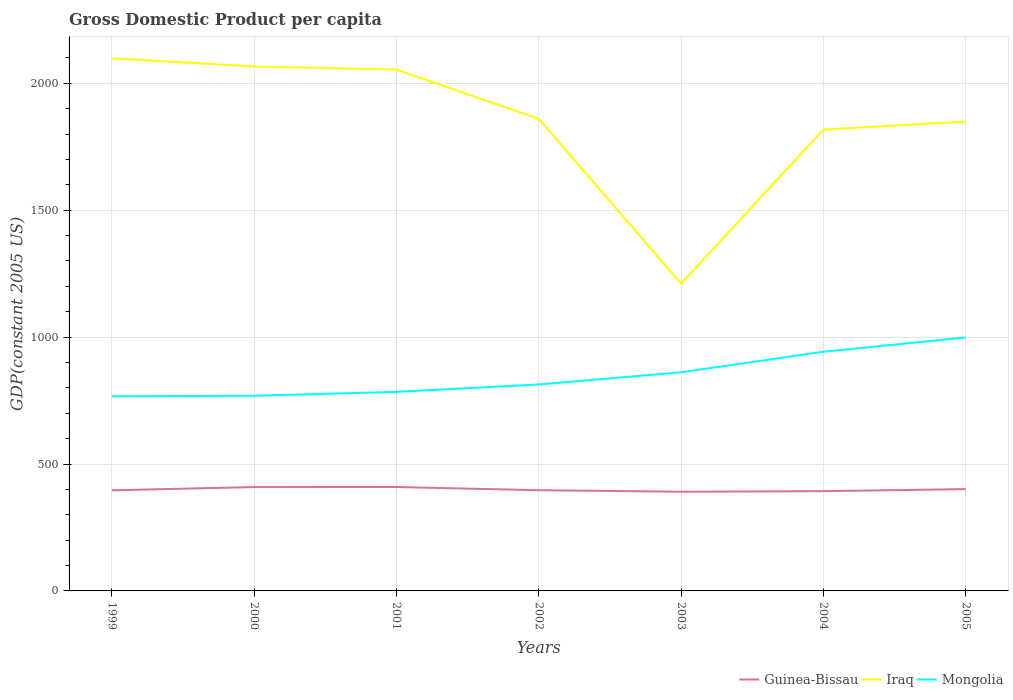How many different coloured lines are there?
Provide a short and direct response. 3. Does the line corresponding to Iraq intersect with the line corresponding to Mongolia?
Give a very brief answer. No. Is the number of lines equal to the number of legend labels?
Offer a very short reply. Yes. Across all years, what is the maximum GDP per capita in Mongolia?
Offer a terse response. 766.98. What is the total GDP per capita in Mongolia in the graph?
Make the answer very short. -175.42. What is the difference between the highest and the second highest GDP per capita in Iraq?
Your answer should be compact. 887.7. What is the difference between the highest and the lowest GDP per capita in Guinea-Bissau?
Offer a terse response. 3. How many lines are there?
Make the answer very short. 3. How many years are there in the graph?
Keep it short and to the point. 7. Does the graph contain any zero values?
Make the answer very short. No. Does the graph contain grids?
Your answer should be very brief. Yes. How are the legend labels stacked?
Make the answer very short. Horizontal. What is the title of the graph?
Your answer should be compact. Gross Domestic Product per capita. Does "Armenia" appear as one of the legend labels in the graph?
Ensure brevity in your answer.  No. What is the label or title of the X-axis?
Your answer should be compact. Years. What is the label or title of the Y-axis?
Provide a succinct answer. GDP(constant 2005 US). What is the GDP(constant 2005 US) of Guinea-Bissau in 1999?
Keep it short and to the point. 396.44. What is the GDP(constant 2005 US) in Iraq in 1999?
Your response must be concise. 2098.73. What is the GDP(constant 2005 US) of Mongolia in 1999?
Your answer should be very brief. 766.98. What is the GDP(constant 2005 US) in Guinea-Bissau in 2000?
Offer a terse response. 409.14. What is the GDP(constant 2005 US) of Iraq in 2000?
Provide a short and direct response. 2066.31. What is the GDP(constant 2005 US) of Mongolia in 2000?
Give a very brief answer. 768.88. What is the GDP(constant 2005 US) of Guinea-Bissau in 2001?
Give a very brief answer. 409.32. What is the GDP(constant 2005 US) of Iraq in 2001?
Provide a short and direct response. 2054.33. What is the GDP(constant 2005 US) of Mongolia in 2001?
Make the answer very short. 784.29. What is the GDP(constant 2005 US) of Guinea-Bissau in 2002?
Give a very brief answer. 396.81. What is the GDP(constant 2005 US) of Iraq in 2002?
Your answer should be very brief. 1860.06. What is the GDP(constant 2005 US) in Mongolia in 2002?
Your answer should be very brief. 813.42. What is the GDP(constant 2005 US) of Guinea-Bissau in 2003?
Your answer should be very brief. 390.71. What is the GDP(constant 2005 US) of Iraq in 2003?
Your response must be concise. 1211.03. What is the GDP(constant 2005 US) in Mongolia in 2003?
Make the answer very short. 861.4. What is the GDP(constant 2005 US) of Guinea-Bissau in 2004?
Give a very brief answer. 393.06. What is the GDP(constant 2005 US) of Iraq in 2004?
Provide a short and direct response. 1817.94. What is the GDP(constant 2005 US) of Mongolia in 2004?
Provide a succinct answer. 942.4. What is the GDP(constant 2005 US) in Guinea-Bissau in 2005?
Your answer should be very brief. 401.15. What is the GDP(constant 2005 US) in Iraq in 2005?
Give a very brief answer. 1848.97. What is the GDP(constant 2005 US) of Mongolia in 2005?
Keep it short and to the point. 998.82. Across all years, what is the maximum GDP(constant 2005 US) of Guinea-Bissau?
Keep it short and to the point. 409.32. Across all years, what is the maximum GDP(constant 2005 US) of Iraq?
Make the answer very short. 2098.73. Across all years, what is the maximum GDP(constant 2005 US) of Mongolia?
Your answer should be very brief. 998.82. Across all years, what is the minimum GDP(constant 2005 US) in Guinea-Bissau?
Offer a very short reply. 390.71. Across all years, what is the minimum GDP(constant 2005 US) of Iraq?
Offer a terse response. 1211.03. Across all years, what is the minimum GDP(constant 2005 US) in Mongolia?
Give a very brief answer. 766.98. What is the total GDP(constant 2005 US) of Guinea-Bissau in the graph?
Offer a terse response. 2796.62. What is the total GDP(constant 2005 US) of Iraq in the graph?
Your answer should be compact. 1.30e+04. What is the total GDP(constant 2005 US) of Mongolia in the graph?
Keep it short and to the point. 5936.19. What is the difference between the GDP(constant 2005 US) in Guinea-Bissau in 1999 and that in 2000?
Your answer should be very brief. -12.7. What is the difference between the GDP(constant 2005 US) of Iraq in 1999 and that in 2000?
Your answer should be very brief. 32.43. What is the difference between the GDP(constant 2005 US) of Mongolia in 1999 and that in 2000?
Keep it short and to the point. -1.91. What is the difference between the GDP(constant 2005 US) in Guinea-Bissau in 1999 and that in 2001?
Keep it short and to the point. -12.89. What is the difference between the GDP(constant 2005 US) of Iraq in 1999 and that in 2001?
Your response must be concise. 44.4. What is the difference between the GDP(constant 2005 US) of Mongolia in 1999 and that in 2001?
Your response must be concise. -17.32. What is the difference between the GDP(constant 2005 US) in Guinea-Bissau in 1999 and that in 2002?
Ensure brevity in your answer.  -0.37. What is the difference between the GDP(constant 2005 US) in Iraq in 1999 and that in 2002?
Provide a short and direct response. 238.67. What is the difference between the GDP(constant 2005 US) in Mongolia in 1999 and that in 2002?
Provide a short and direct response. -46.45. What is the difference between the GDP(constant 2005 US) in Guinea-Bissau in 1999 and that in 2003?
Provide a short and direct response. 5.73. What is the difference between the GDP(constant 2005 US) in Iraq in 1999 and that in 2003?
Provide a short and direct response. 887.7. What is the difference between the GDP(constant 2005 US) in Mongolia in 1999 and that in 2003?
Provide a short and direct response. -94.42. What is the difference between the GDP(constant 2005 US) of Guinea-Bissau in 1999 and that in 2004?
Make the answer very short. 3.38. What is the difference between the GDP(constant 2005 US) in Iraq in 1999 and that in 2004?
Offer a very short reply. 280.79. What is the difference between the GDP(constant 2005 US) of Mongolia in 1999 and that in 2004?
Offer a terse response. -175.42. What is the difference between the GDP(constant 2005 US) in Guinea-Bissau in 1999 and that in 2005?
Your response must be concise. -4.71. What is the difference between the GDP(constant 2005 US) in Iraq in 1999 and that in 2005?
Offer a very short reply. 249.76. What is the difference between the GDP(constant 2005 US) of Mongolia in 1999 and that in 2005?
Provide a succinct answer. -231.85. What is the difference between the GDP(constant 2005 US) of Guinea-Bissau in 2000 and that in 2001?
Keep it short and to the point. -0.18. What is the difference between the GDP(constant 2005 US) of Iraq in 2000 and that in 2001?
Your answer should be compact. 11.97. What is the difference between the GDP(constant 2005 US) of Mongolia in 2000 and that in 2001?
Provide a short and direct response. -15.41. What is the difference between the GDP(constant 2005 US) in Guinea-Bissau in 2000 and that in 2002?
Make the answer very short. 12.33. What is the difference between the GDP(constant 2005 US) of Iraq in 2000 and that in 2002?
Make the answer very short. 206.25. What is the difference between the GDP(constant 2005 US) in Mongolia in 2000 and that in 2002?
Offer a terse response. -44.54. What is the difference between the GDP(constant 2005 US) of Guinea-Bissau in 2000 and that in 2003?
Your answer should be very brief. 18.43. What is the difference between the GDP(constant 2005 US) in Iraq in 2000 and that in 2003?
Keep it short and to the point. 855.28. What is the difference between the GDP(constant 2005 US) of Mongolia in 2000 and that in 2003?
Make the answer very short. -92.51. What is the difference between the GDP(constant 2005 US) of Guinea-Bissau in 2000 and that in 2004?
Make the answer very short. 16.08. What is the difference between the GDP(constant 2005 US) in Iraq in 2000 and that in 2004?
Ensure brevity in your answer.  248.36. What is the difference between the GDP(constant 2005 US) in Mongolia in 2000 and that in 2004?
Your answer should be very brief. -173.51. What is the difference between the GDP(constant 2005 US) in Guinea-Bissau in 2000 and that in 2005?
Keep it short and to the point. 7.99. What is the difference between the GDP(constant 2005 US) of Iraq in 2000 and that in 2005?
Give a very brief answer. 217.34. What is the difference between the GDP(constant 2005 US) in Mongolia in 2000 and that in 2005?
Your response must be concise. -229.94. What is the difference between the GDP(constant 2005 US) of Guinea-Bissau in 2001 and that in 2002?
Provide a short and direct response. 12.51. What is the difference between the GDP(constant 2005 US) of Iraq in 2001 and that in 2002?
Make the answer very short. 194.28. What is the difference between the GDP(constant 2005 US) of Mongolia in 2001 and that in 2002?
Your answer should be very brief. -29.13. What is the difference between the GDP(constant 2005 US) in Guinea-Bissau in 2001 and that in 2003?
Offer a very short reply. 18.61. What is the difference between the GDP(constant 2005 US) of Iraq in 2001 and that in 2003?
Your answer should be very brief. 843.31. What is the difference between the GDP(constant 2005 US) in Mongolia in 2001 and that in 2003?
Keep it short and to the point. -77.1. What is the difference between the GDP(constant 2005 US) in Guinea-Bissau in 2001 and that in 2004?
Provide a short and direct response. 16.27. What is the difference between the GDP(constant 2005 US) in Iraq in 2001 and that in 2004?
Give a very brief answer. 236.39. What is the difference between the GDP(constant 2005 US) of Mongolia in 2001 and that in 2004?
Provide a succinct answer. -158.1. What is the difference between the GDP(constant 2005 US) in Guinea-Bissau in 2001 and that in 2005?
Ensure brevity in your answer.  8.18. What is the difference between the GDP(constant 2005 US) in Iraq in 2001 and that in 2005?
Your response must be concise. 205.36. What is the difference between the GDP(constant 2005 US) of Mongolia in 2001 and that in 2005?
Provide a succinct answer. -214.53. What is the difference between the GDP(constant 2005 US) in Guinea-Bissau in 2002 and that in 2003?
Offer a terse response. 6.1. What is the difference between the GDP(constant 2005 US) of Iraq in 2002 and that in 2003?
Your answer should be very brief. 649.03. What is the difference between the GDP(constant 2005 US) in Mongolia in 2002 and that in 2003?
Your response must be concise. -47.97. What is the difference between the GDP(constant 2005 US) in Guinea-Bissau in 2002 and that in 2004?
Give a very brief answer. 3.75. What is the difference between the GDP(constant 2005 US) of Iraq in 2002 and that in 2004?
Your response must be concise. 42.11. What is the difference between the GDP(constant 2005 US) of Mongolia in 2002 and that in 2004?
Make the answer very short. -128.97. What is the difference between the GDP(constant 2005 US) in Guinea-Bissau in 2002 and that in 2005?
Make the answer very short. -4.34. What is the difference between the GDP(constant 2005 US) of Iraq in 2002 and that in 2005?
Ensure brevity in your answer.  11.09. What is the difference between the GDP(constant 2005 US) of Mongolia in 2002 and that in 2005?
Keep it short and to the point. -185.4. What is the difference between the GDP(constant 2005 US) in Guinea-Bissau in 2003 and that in 2004?
Provide a succinct answer. -2.35. What is the difference between the GDP(constant 2005 US) of Iraq in 2003 and that in 2004?
Offer a very short reply. -606.92. What is the difference between the GDP(constant 2005 US) in Mongolia in 2003 and that in 2004?
Give a very brief answer. -81. What is the difference between the GDP(constant 2005 US) in Guinea-Bissau in 2003 and that in 2005?
Ensure brevity in your answer.  -10.44. What is the difference between the GDP(constant 2005 US) in Iraq in 2003 and that in 2005?
Offer a very short reply. -637.94. What is the difference between the GDP(constant 2005 US) of Mongolia in 2003 and that in 2005?
Make the answer very short. -137.43. What is the difference between the GDP(constant 2005 US) of Guinea-Bissau in 2004 and that in 2005?
Your answer should be very brief. -8.09. What is the difference between the GDP(constant 2005 US) in Iraq in 2004 and that in 2005?
Your response must be concise. -31.02. What is the difference between the GDP(constant 2005 US) of Mongolia in 2004 and that in 2005?
Provide a short and direct response. -56.43. What is the difference between the GDP(constant 2005 US) of Guinea-Bissau in 1999 and the GDP(constant 2005 US) of Iraq in 2000?
Your response must be concise. -1669.87. What is the difference between the GDP(constant 2005 US) of Guinea-Bissau in 1999 and the GDP(constant 2005 US) of Mongolia in 2000?
Keep it short and to the point. -372.45. What is the difference between the GDP(constant 2005 US) of Iraq in 1999 and the GDP(constant 2005 US) of Mongolia in 2000?
Offer a terse response. 1329.85. What is the difference between the GDP(constant 2005 US) of Guinea-Bissau in 1999 and the GDP(constant 2005 US) of Iraq in 2001?
Your answer should be compact. -1657.9. What is the difference between the GDP(constant 2005 US) of Guinea-Bissau in 1999 and the GDP(constant 2005 US) of Mongolia in 2001?
Provide a succinct answer. -387.86. What is the difference between the GDP(constant 2005 US) in Iraq in 1999 and the GDP(constant 2005 US) in Mongolia in 2001?
Offer a terse response. 1314.44. What is the difference between the GDP(constant 2005 US) in Guinea-Bissau in 1999 and the GDP(constant 2005 US) in Iraq in 2002?
Give a very brief answer. -1463.62. What is the difference between the GDP(constant 2005 US) of Guinea-Bissau in 1999 and the GDP(constant 2005 US) of Mongolia in 2002?
Your answer should be compact. -416.99. What is the difference between the GDP(constant 2005 US) in Iraq in 1999 and the GDP(constant 2005 US) in Mongolia in 2002?
Keep it short and to the point. 1285.31. What is the difference between the GDP(constant 2005 US) in Guinea-Bissau in 1999 and the GDP(constant 2005 US) in Iraq in 2003?
Offer a terse response. -814.59. What is the difference between the GDP(constant 2005 US) of Guinea-Bissau in 1999 and the GDP(constant 2005 US) of Mongolia in 2003?
Ensure brevity in your answer.  -464.96. What is the difference between the GDP(constant 2005 US) of Iraq in 1999 and the GDP(constant 2005 US) of Mongolia in 2003?
Your response must be concise. 1237.34. What is the difference between the GDP(constant 2005 US) in Guinea-Bissau in 1999 and the GDP(constant 2005 US) in Iraq in 2004?
Ensure brevity in your answer.  -1421.51. What is the difference between the GDP(constant 2005 US) in Guinea-Bissau in 1999 and the GDP(constant 2005 US) in Mongolia in 2004?
Offer a terse response. -545.96. What is the difference between the GDP(constant 2005 US) in Iraq in 1999 and the GDP(constant 2005 US) in Mongolia in 2004?
Provide a succinct answer. 1156.34. What is the difference between the GDP(constant 2005 US) in Guinea-Bissau in 1999 and the GDP(constant 2005 US) in Iraq in 2005?
Ensure brevity in your answer.  -1452.53. What is the difference between the GDP(constant 2005 US) in Guinea-Bissau in 1999 and the GDP(constant 2005 US) in Mongolia in 2005?
Your answer should be compact. -602.39. What is the difference between the GDP(constant 2005 US) in Iraq in 1999 and the GDP(constant 2005 US) in Mongolia in 2005?
Provide a succinct answer. 1099.91. What is the difference between the GDP(constant 2005 US) in Guinea-Bissau in 2000 and the GDP(constant 2005 US) in Iraq in 2001?
Ensure brevity in your answer.  -1645.19. What is the difference between the GDP(constant 2005 US) in Guinea-Bissau in 2000 and the GDP(constant 2005 US) in Mongolia in 2001?
Your answer should be very brief. -375.15. What is the difference between the GDP(constant 2005 US) in Iraq in 2000 and the GDP(constant 2005 US) in Mongolia in 2001?
Make the answer very short. 1282.01. What is the difference between the GDP(constant 2005 US) in Guinea-Bissau in 2000 and the GDP(constant 2005 US) in Iraq in 2002?
Your response must be concise. -1450.92. What is the difference between the GDP(constant 2005 US) of Guinea-Bissau in 2000 and the GDP(constant 2005 US) of Mongolia in 2002?
Make the answer very short. -404.28. What is the difference between the GDP(constant 2005 US) in Iraq in 2000 and the GDP(constant 2005 US) in Mongolia in 2002?
Provide a succinct answer. 1252.88. What is the difference between the GDP(constant 2005 US) of Guinea-Bissau in 2000 and the GDP(constant 2005 US) of Iraq in 2003?
Your answer should be compact. -801.89. What is the difference between the GDP(constant 2005 US) in Guinea-Bissau in 2000 and the GDP(constant 2005 US) in Mongolia in 2003?
Offer a very short reply. -452.26. What is the difference between the GDP(constant 2005 US) in Iraq in 2000 and the GDP(constant 2005 US) in Mongolia in 2003?
Ensure brevity in your answer.  1204.91. What is the difference between the GDP(constant 2005 US) of Guinea-Bissau in 2000 and the GDP(constant 2005 US) of Iraq in 2004?
Provide a succinct answer. -1408.8. What is the difference between the GDP(constant 2005 US) in Guinea-Bissau in 2000 and the GDP(constant 2005 US) in Mongolia in 2004?
Provide a succinct answer. -533.26. What is the difference between the GDP(constant 2005 US) of Iraq in 2000 and the GDP(constant 2005 US) of Mongolia in 2004?
Keep it short and to the point. 1123.91. What is the difference between the GDP(constant 2005 US) of Guinea-Bissau in 2000 and the GDP(constant 2005 US) of Iraq in 2005?
Provide a succinct answer. -1439.83. What is the difference between the GDP(constant 2005 US) of Guinea-Bissau in 2000 and the GDP(constant 2005 US) of Mongolia in 2005?
Provide a short and direct response. -589.68. What is the difference between the GDP(constant 2005 US) of Iraq in 2000 and the GDP(constant 2005 US) of Mongolia in 2005?
Provide a short and direct response. 1067.48. What is the difference between the GDP(constant 2005 US) of Guinea-Bissau in 2001 and the GDP(constant 2005 US) of Iraq in 2002?
Make the answer very short. -1450.73. What is the difference between the GDP(constant 2005 US) of Guinea-Bissau in 2001 and the GDP(constant 2005 US) of Mongolia in 2002?
Your answer should be very brief. -404.1. What is the difference between the GDP(constant 2005 US) in Iraq in 2001 and the GDP(constant 2005 US) in Mongolia in 2002?
Make the answer very short. 1240.91. What is the difference between the GDP(constant 2005 US) of Guinea-Bissau in 2001 and the GDP(constant 2005 US) of Iraq in 2003?
Your answer should be compact. -801.7. What is the difference between the GDP(constant 2005 US) of Guinea-Bissau in 2001 and the GDP(constant 2005 US) of Mongolia in 2003?
Keep it short and to the point. -452.07. What is the difference between the GDP(constant 2005 US) in Iraq in 2001 and the GDP(constant 2005 US) in Mongolia in 2003?
Offer a terse response. 1192.94. What is the difference between the GDP(constant 2005 US) in Guinea-Bissau in 2001 and the GDP(constant 2005 US) in Iraq in 2004?
Give a very brief answer. -1408.62. What is the difference between the GDP(constant 2005 US) of Guinea-Bissau in 2001 and the GDP(constant 2005 US) of Mongolia in 2004?
Your answer should be very brief. -533.07. What is the difference between the GDP(constant 2005 US) in Iraq in 2001 and the GDP(constant 2005 US) in Mongolia in 2004?
Offer a very short reply. 1111.94. What is the difference between the GDP(constant 2005 US) in Guinea-Bissau in 2001 and the GDP(constant 2005 US) in Iraq in 2005?
Your answer should be compact. -1439.64. What is the difference between the GDP(constant 2005 US) in Guinea-Bissau in 2001 and the GDP(constant 2005 US) in Mongolia in 2005?
Your answer should be very brief. -589.5. What is the difference between the GDP(constant 2005 US) of Iraq in 2001 and the GDP(constant 2005 US) of Mongolia in 2005?
Offer a terse response. 1055.51. What is the difference between the GDP(constant 2005 US) of Guinea-Bissau in 2002 and the GDP(constant 2005 US) of Iraq in 2003?
Your response must be concise. -814.22. What is the difference between the GDP(constant 2005 US) of Guinea-Bissau in 2002 and the GDP(constant 2005 US) of Mongolia in 2003?
Make the answer very short. -464.59. What is the difference between the GDP(constant 2005 US) in Iraq in 2002 and the GDP(constant 2005 US) in Mongolia in 2003?
Ensure brevity in your answer.  998.66. What is the difference between the GDP(constant 2005 US) of Guinea-Bissau in 2002 and the GDP(constant 2005 US) of Iraq in 2004?
Provide a succinct answer. -1421.13. What is the difference between the GDP(constant 2005 US) of Guinea-Bissau in 2002 and the GDP(constant 2005 US) of Mongolia in 2004?
Make the answer very short. -545.59. What is the difference between the GDP(constant 2005 US) in Iraq in 2002 and the GDP(constant 2005 US) in Mongolia in 2004?
Provide a short and direct response. 917.66. What is the difference between the GDP(constant 2005 US) of Guinea-Bissau in 2002 and the GDP(constant 2005 US) of Iraq in 2005?
Ensure brevity in your answer.  -1452.16. What is the difference between the GDP(constant 2005 US) in Guinea-Bissau in 2002 and the GDP(constant 2005 US) in Mongolia in 2005?
Offer a very short reply. -602.01. What is the difference between the GDP(constant 2005 US) in Iraq in 2002 and the GDP(constant 2005 US) in Mongolia in 2005?
Offer a terse response. 861.24. What is the difference between the GDP(constant 2005 US) of Guinea-Bissau in 2003 and the GDP(constant 2005 US) of Iraq in 2004?
Keep it short and to the point. -1427.23. What is the difference between the GDP(constant 2005 US) in Guinea-Bissau in 2003 and the GDP(constant 2005 US) in Mongolia in 2004?
Offer a very short reply. -551.69. What is the difference between the GDP(constant 2005 US) of Iraq in 2003 and the GDP(constant 2005 US) of Mongolia in 2004?
Provide a succinct answer. 268.63. What is the difference between the GDP(constant 2005 US) of Guinea-Bissau in 2003 and the GDP(constant 2005 US) of Iraq in 2005?
Provide a succinct answer. -1458.26. What is the difference between the GDP(constant 2005 US) in Guinea-Bissau in 2003 and the GDP(constant 2005 US) in Mongolia in 2005?
Provide a short and direct response. -608.11. What is the difference between the GDP(constant 2005 US) in Iraq in 2003 and the GDP(constant 2005 US) in Mongolia in 2005?
Give a very brief answer. 212.2. What is the difference between the GDP(constant 2005 US) in Guinea-Bissau in 2004 and the GDP(constant 2005 US) in Iraq in 2005?
Your answer should be compact. -1455.91. What is the difference between the GDP(constant 2005 US) in Guinea-Bissau in 2004 and the GDP(constant 2005 US) in Mongolia in 2005?
Ensure brevity in your answer.  -605.76. What is the difference between the GDP(constant 2005 US) of Iraq in 2004 and the GDP(constant 2005 US) of Mongolia in 2005?
Your response must be concise. 819.12. What is the average GDP(constant 2005 US) in Guinea-Bissau per year?
Provide a short and direct response. 399.52. What is the average GDP(constant 2005 US) of Iraq per year?
Provide a succinct answer. 1851.05. What is the average GDP(constant 2005 US) of Mongolia per year?
Make the answer very short. 848.03. In the year 1999, what is the difference between the GDP(constant 2005 US) of Guinea-Bissau and GDP(constant 2005 US) of Iraq?
Provide a short and direct response. -1702.3. In the year 1999, what is the difference between the GDP(constant 2005 US) in Guinea-Bissau and GDP(constant 2005 US) in Mongolia?
Make the answer very short. -370.54. In the year 1999, what is the difference between the GDP(constant 2005 US) of Iraq and GDP(constant 2005 US) of Mongolia?
Offer a very short reply. 1331.76. In the year 2000, what is the difference between the GDP(constant 2005 US) in Guinea-Bissau and GDP(constant 2005 US) in Iraq?
Make the answer very short. -1657.17. In the year 2000, what is the difference between the GDP(constant 2005 US) of Guinea-Bissau and GDP(constant 2005 US) of Mongolia?
Keep it short and to the point. -359.74. In the year 2000, what is the difference between the GDP(constant 2005 US) of Iraq and GDP(constant 2005 US) of Mongolia?
Offer a very short reply. 1297.42. In the year 2001, what is the difference between the GDP(constant 2005 US) of Guinea-Bissau and GDP(constant 2005 US) of Iraq?
Your response must be concise. -1645.01. In the year 2001, what is the difference between the GDP(constant 2005 US) of Guinea-Bissau and GDP(constant 2005 US) of Mongolia?
Your answer should be compact. -374.97. In the year 2001, what is the difference between the GDP(constant 2005 US) of Iraq and GDP(constant 2005 US) of Mongolia?
Offer a terse response. 1270.04. In the year 2002, what is the difference between the GDP(constant 2005 US) in Guinea-Bissau and GDP(constant 2005 US) in Iraq?
Your answer should be compact. -1463.25. In the year 2002, what is the difference between the GDP(constant 2005 US) of Guinea-Bissau and GDP(constant 2005 US) of Mongolia?
Make the answer very short. -416.61. In the year 2002, what is the difference between the GDP(constant 2005 US) of Iraq and GDP(constant 2005 US) of Mongolia?
Make the answer very short. 1046.64. In the year 2003, what is the difference between the GDP(constant 2005 US) of Guinea-Bissau and GDP(constant 2005 US) of Iraq?
Provide a short and direct response. -820.32. In the year 2003, what is the difference between the GDP(constant 2005 US) of Guinea-Bissau and GDP(constant 2005 US) of Mongolia?
Your response must be concise. -470.69. In the year 2003, what is the difference between the GDP(constant 2005 US) of Iraq and GDP(constant 2005 US) of Mongolia?
Your response must be concise. 349.63. In the year 2004, what is the difference between the GDP(constant 2005 US) in Guinea-Bissau and GDP(constant 2005 US) in Iraq?
Offer a very short reply. -1424.89. In the year 2004, what is the difference between the GDP(constant 2005 US) of Guinea-Bissau and GDP(constant 2005 US) of Mongolia?
Ensure brevity in your answer.  -549.34. In the year 2004, what is the difference between the GDP(constant 2005 US) of Iraq and GDP(constant 2005 US) of Mongolia?
Your answer should be compact. 875.55. In the year 2005, what is the difference between the GDP(constant 2005 US) of Guinea-Bissau and GDP(constant 2005 US) of Iraq?
Your answer should be very brief. -1447.82. In the year 2005, what is the difference between the GDP(constant 2005 US) in Guinea-Bissau and GDP(constant 2005 US) in Mongolia?
Keep it short and to the point. -597.67. In the year 2005, what is the difference between the GDP(constant 2005 US) of Iraq and GDP(constant 2005 US) of Mongolia?
Make the answer very short. 850.15. What is the ratio of the GDP(constant 2005 US) of Guinea-Bissau in 1999 to that in 2000?
Provide a short and direct response. 0.97. What is the ratio of the GDP(constant 2005 US) of Iraq in 1999 to that in 2000?
Your answer should be compact. 1.02. What is the ratio of the GDP(constant 2005 US) of Mongolia in 1999 to that in 2000?
Offer a terse response. 1. What is the ratio of the GDP(constant 2005 US) in Guinea-Bissau in 1999 to that in 2001?
Your response must be concise. 0.97. What is the ratio of the GDP(constant 2005 US) in Iraq in 1999 to that in 2001?
Offer a terse response. 1.02. What is the ratio of the GDP(constant 2005 US) of Mongolia in 1999 to that in 2001?
Provide a short and direct response. 0.98. What is the ratio of the GDP(constant 2005 US) of Guinea-Bissau in 1999 to that in 2002?
Keep it short and to the point. 1. What is the ratio of the GDP(constant 2005 US) of Iraq in 1999 to that in 2002?
Offer a terse response. 1.13. What is the ratio of the GDP(constant 2005 US) in Mongolia in 1999 to that in 2002?
Make the answer very short. 0.94. What is the ratio of the GDP(constant 2005 US) of Guinea-Bissau in 1999 to that in 2003?
Your answer should be compact. 1.01. What is the ratio of the GDP(constant 2005 US) in Iraq in 1999 to that in 2003?
Make the answer very short. 1.73. What is the ratio of the GDP(constant 2005 US) in Mongolia in 1999 to that in 2003?
Provide a succinct answer. 0.89. What is the ratio of the GDP(constant 2005 US) of Guinea-Bissau in 1999 to that in 2004?
Give a very brief answer. 1.01. What is the ratio of the GDP(constant 2005 US) in Iraq in 1999 to that in 2004?
Provide a short and direct response. 1.15. What is the ratio of the GDP(constant 2005 US) of Mongolia in 1999 to that in 2004?
Give a very brief answer. 0.81. What is the ratio of the GDP(constant 2005 US) in Guinea-Bissau in 1999 to that in 2005?
Offer a terse response. 0.99. What is the ratio of the GDP(constant 2005 US) in Iraq in 1999 to that in 2005?
Your answer should be compact. 1.14. What is the ratio of the GDP(constant 2005 US) of Mongolia in 1999 to that in 2005?
Make the answer very short. 0.77. What is the ratio of the GDP(constant 2005 US) in Guinea-Bissau in 2000 to that in 2001?
Offer a very short reply. 1. What is the ratio of the GDP(constant 2005 US) of Iraq in 2000 to that in 2001?
Offer a very short reply. 1.01. What is the ratio of the GDP(constant 2005 US) of Mongolia in 2000 to that in 2001?
Make the answer very short. 0.98. What is the ratio of the GDP(constant 2005 US) in Guinea-Bissau in 2000 to that in 2002?
Keep it short and to the point. 1.03. What is the ratio of the GDP(constant 2005 US) of Iraq in 2000 to that in 2002?
Provide a short and direct response. 1.11. What is the ratio of the GDP(constant 2005 US) in Mongolia in 2000 to that in 2002?
Give a very brief answer. 0.95. What is the ratio of the GDP(constant 2005 US) in Guinea-Bissau in 2000 to that in 2003?
Your answer should be compact. 1.05. What is the ratio of the GDP(constant 2005 US) in Iraq in 2000 to that in 2003?
Your answer should be compact. 1.71. What is the ratio of the GDP(constant 2005 US) of Mongolia in 2000 to that in 2003?
Provide a short and direct response. 0.89. What is the ratio of the GDP(constant 2005 US) of Guinea-Bissau in 2000 to that in 2004?
Your response must be concise. 1.04. What is the ratio of the GDP(constant 2005 US) of Iraq in 2000 to that in 2004?
Your answer should be very brief. 1.14. What is the ratio of the GDP(constant 2005 US) in Mongolia in 2000 to that in 2004?
Provide a succinct answer. 0.82. What is the ratio of the GDP(constant 2005 US) of Guinea-Bissau in 2000 to that in 2005?
Ensure brevity in your answer.  1.02. What is the ratio of the GDP(constant 2005 US) of Iraq in 2000 to that in 2005?
Ensure brevity in your answer.  1.12. What is the ratio of the GDP(constant 2005 US) of Mongolia in 2000 to that in 2005?
Your answer should be compact. 0.77. What is the ratio of the GDP(constant 2005 US) of Guinea-Bissau in 2001 to that in 2002?
Offer a very short reply. 1.03. What is the ratio of the GDP(constant 2005 US) in Iraq in 2001 to that in 2002?
Your answer should be very brief. 1.1. What is the ratio of the GDP(constant 2005 US) of Mongolia in 2001 to that in 2002?
Your answer should be very brief. 0.96. What is the ratio of the GDP(constant 2005 US) in Guinea-Bissau in 2001 to that in 2003?
Keep it short and to the point. 1.05. What is the ratio of the GDP(constant 2005 US) in Iraq in 2001 to that in 2003?
Ensure brevity in your answer.  1.7. What is the ratio of the GDP(constant 2005 US) in Mongolia in 2001 to that in 2003?
Make the answer very short. 0.91. What is the ratio of the GDP(constant 2005 US) in Guinea-Bissau in 2001 to that in 2004?
Ensure brevity in your answer.  1.04. What is the ratio of the GDP(constant 2005 US) of Iraq in 2001 to that in 2004?
Your answer should be very brief. 1.13. What is the ratio of the GDP(constant 2005 US) of Mongolia in 2001 to that in 2004?
Make the answer very short. 0.83. What is the ratio of the GDP(constant 2005 US) of Guinea-Bissau in 2001 to that in 2005?
Keep it short and to the point. 1.02. What is the ratio of the GDP(constant 2005 US) in Mongolia in 2001 to that in 2005?
Keep it short and to the point. 0.79. What is the ratio of the GDP(constant 2005 US) of Guinea-Bissau in 2002 to that in 2003?
Ensure brevity in your answer.  1.02. What is the ratio of the GDP(constant 2005 US) in Iraq in 2002 to that in 2003?
Provide a succinct answer. 1.54. What is the ratio of the GDP(constant 2005 US) of Mongolia in 2002 to that in 2003?
Make the answer very short. 0.94. What is the ratio of the GDP(constant 2005 US) in Guinea-Bissau in 2002 to that in 2004?
Your response must be concise. 1.01. What is the ratio of the GDP(constant 2005 US) of Iraq in 2002 to that in 2004?
Your answer should be compact. 1.02. What is the ratio of the GDP(constant 2005 US) of Mongolia in 2002 to that in 2004?
Give a very brief answer. 0.86. What is the ratio of the GDP(constant 2005 US) of Iraq in 2002 to that in 2005?
Provide a succinct answer. 1.01. What is the ratio of the GDP(constant 2005 US) in Mongolia in 2002 to that in 2005?
Your answer should be compact. 0.81. What is the ratio of the GDP(constant 2005 US) in Guinea-Bissau in 2003 to that in 2004?
Provide a short and direct response. 0.99. What is the ratio of the GDP(constant 2005 US) in Iraq in 2003 to that in 2004?
Your response must be concise. 0.67. What is the ratio of the GDP(constant 2005 US) of Mongolia in 2003 to that in 2004?
Ensure brevity in your answer.  0.91. What is the ratio of the GDP(constant 2005 US) in Iraq in 2003 to that in 2005?
Your answer should be very brief. 0.66. What is the ratio of the GDP(constant 2005 US) in Mongolia in 2003 to that in 2005?
Your answer should be very brief. 0.86. What is the ratio of the GDP(constant 2005 US) in Guinea-Bissau in 2004 to that in 2005?
Your answer should be very brief. 0.98. What is the ratio of the GDP(constant 2005 US) in Iraq in 2004 to that in 2005?
Give a very brief answer. 0.98. What is the ratio of the GDP(constant 2005 US) in Mongolia in 2004 to that in 2005?
Give a very brief answer. 0.94. What is the difference between the highest and the second highest GDP(constant 2005 US) of Guinea-Bissau?
Make the answer very short. 0.18. What is the difference between the highest and the second highest GDP(constant 2005 US) in Iraq?
Offer a terse response. 32.43. What is the difference between the highest and the second highest GDP(constant 2005 US) of Mongolia?
Provide a short and direct response. 56.43. What is the difference between the highest and the lowest GDP(constant 2005 US) of Guinea-Bissau?
Provide a short and direct response. 18.61. What is the difference between the highest and the lowest GDP(constant 2005 US) in Iraq?
Your answer should be very brief. 887.7. What is the difference between the highest and the lowest GDP(constant 2005 US) of Mongolia?
Make the answer very short. 231.85. 